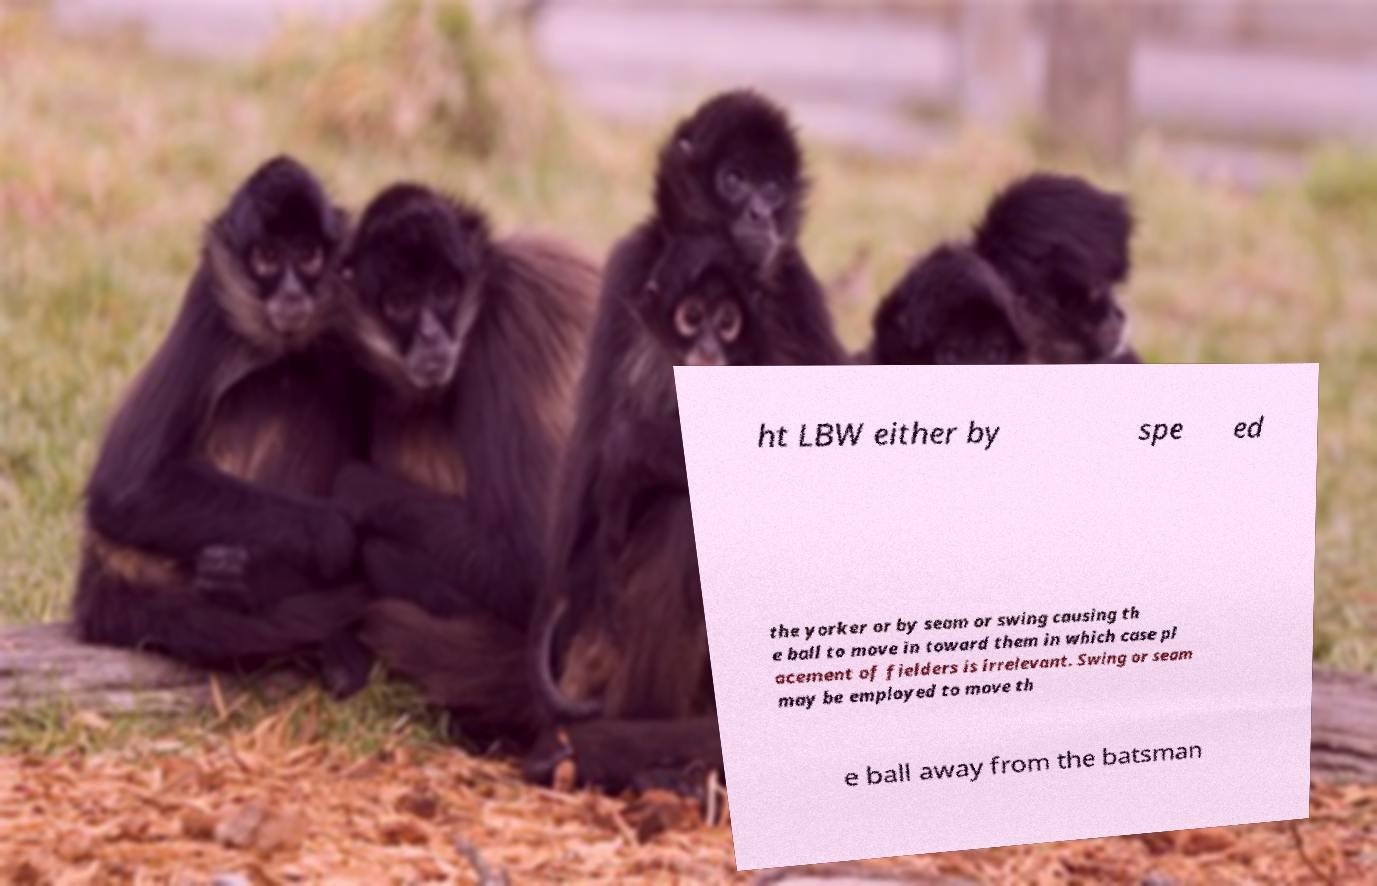For documentation purposes, I need the text within this image transcribed. Could you provide that? ht LBW either by spe ed the yorker or by seam or swing causing th e ball to move in toward them in which case pl acement of fielders is irrelevant. Swing or seam may be employed to move th e ball away from the batsman 